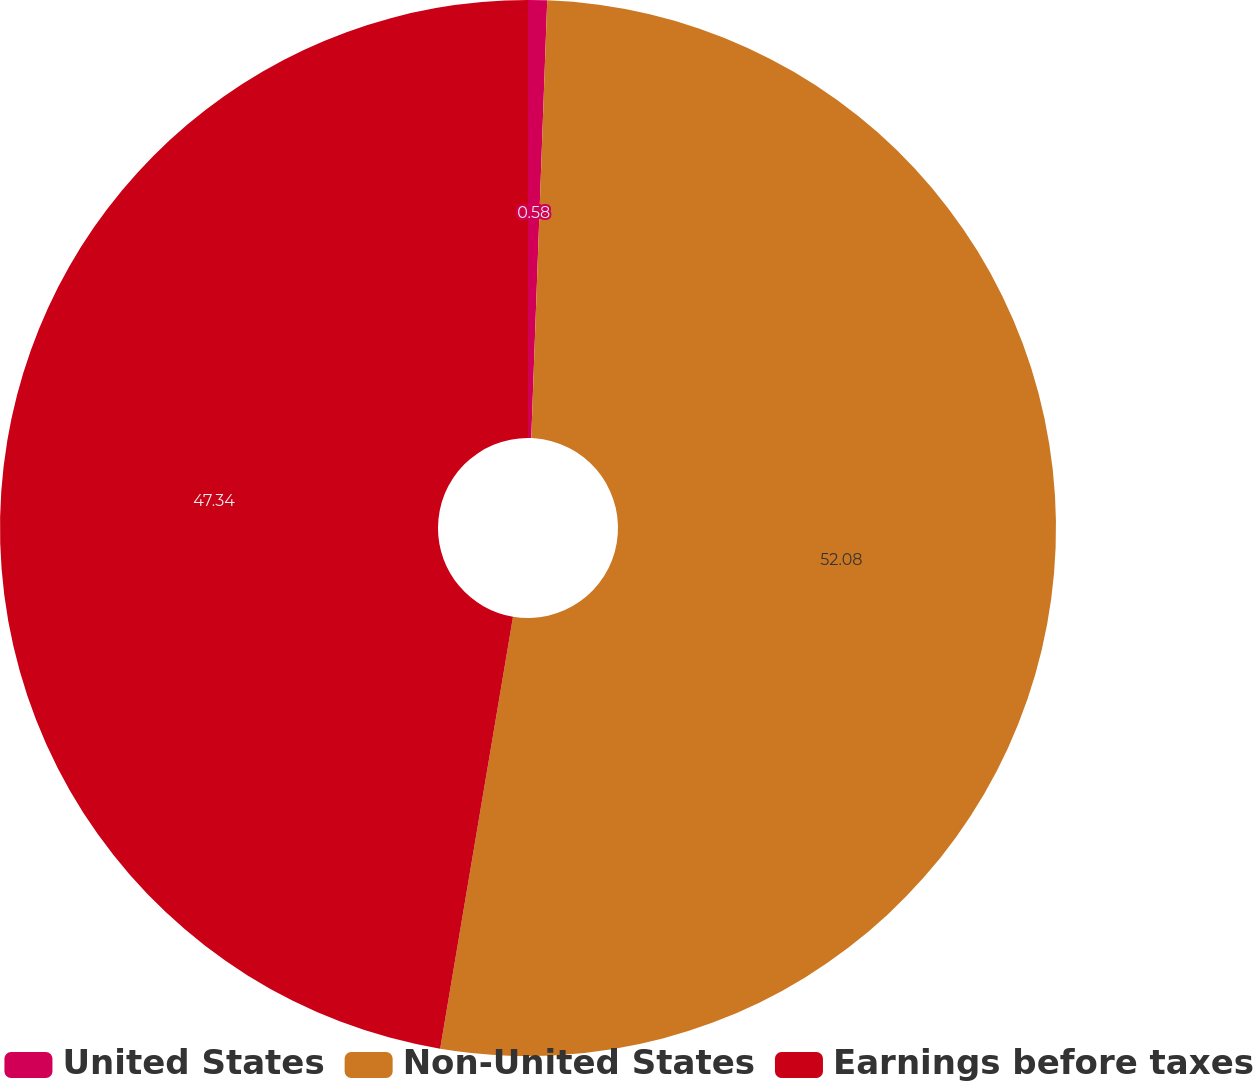<chart> <loc_0><loc_0><loc_500><loc_500><pie_chart><fcel>United States<fcel>Non-United States<fcel>Earnings before taxes<nl><fcel>0.58%<fcel>52.08%<fcel>47.34%<nl></chart> 